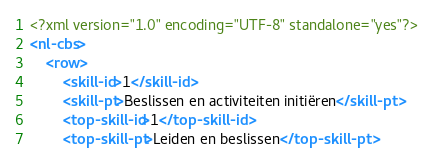Convert code to text. <code><loc_0><loc_0><loc_500><loc_500><_XML_><?xml version="1.0" encoding="UTF-8" standalone="yes"?>
<nl-cbs>
	<row>
		<skill-id>1</skill-id>
		<skill-pt>Beslissen en activiteiten initiëren</skill-pt>
		<top-skill-id>1</top-skill-id>
		<top-skill-pt>Leiden en beslissen</top-skill-pt></code> 